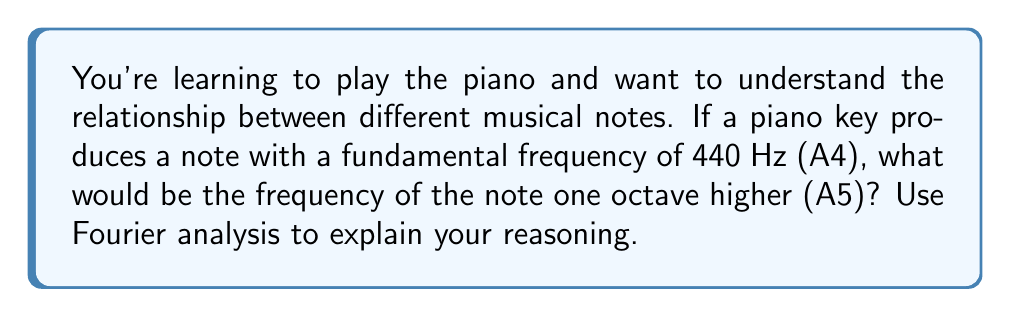Can you answer this question? Let's approach this step-by-step using Fourier analysis:

1) In Fourier analysis, any periodic signal (like a musical note) can be represented as a sum of sinusoidal waves with different frequencies.

2) The fundamental frequency (f) is the lowest frequency component in this sum. For A4, f = 440 Hz.

3) The Fourier series for a musical note includes harmonics, which are integer multiples of the fundamental frequency:

   $$f_n = n \cdot f$$

   where n = 1, 2, 3, ...

4) The first harmonic (n = 1) is the fundamental frequency itself.

5) In Western music, an octave represents a doubling of frequency. So, to find the frequency of A5, we need to double the frequency of A4:

   $$f_{A5} = 2 \cdot f_{A4} = 2 \cdot 440 \text{ Hz} = 880 \text{ Hz}$$

6) We can verify this using Fourier analysis. The second harmonic (n = 2) of A4 is:

   $$f_2 = 2 \cdot 440 \text{ Hz} = 880 \text{ Hz}$$

7) This matches our calculation for A5, confirming that A5 is indeed the second harmonic of A4.

8) In terms of the Fourier series, A5 would have its own fundamental frequency of 880 Hz, and its harmonics would be integer multiples of this new fundamental.
Answer: 880 Hz 